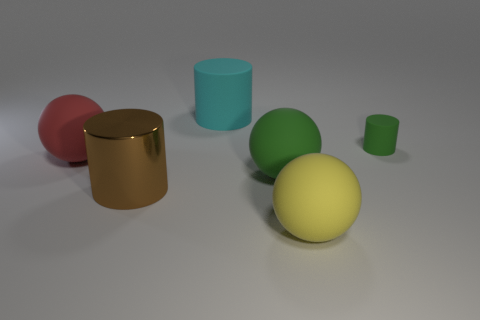Add 3 blue rubber cylinders. How many objects exist? 9 Add 6 cyan cylinders. How many cyan cylinders are left? 7 Add 4 big yellow things. How many big yellow things exist? 5 Subtract 1 cyan cylinders. How many objects are left? 5 Subtract all small green metal things. Subtract all small cylinders. How many objects are left? 5 